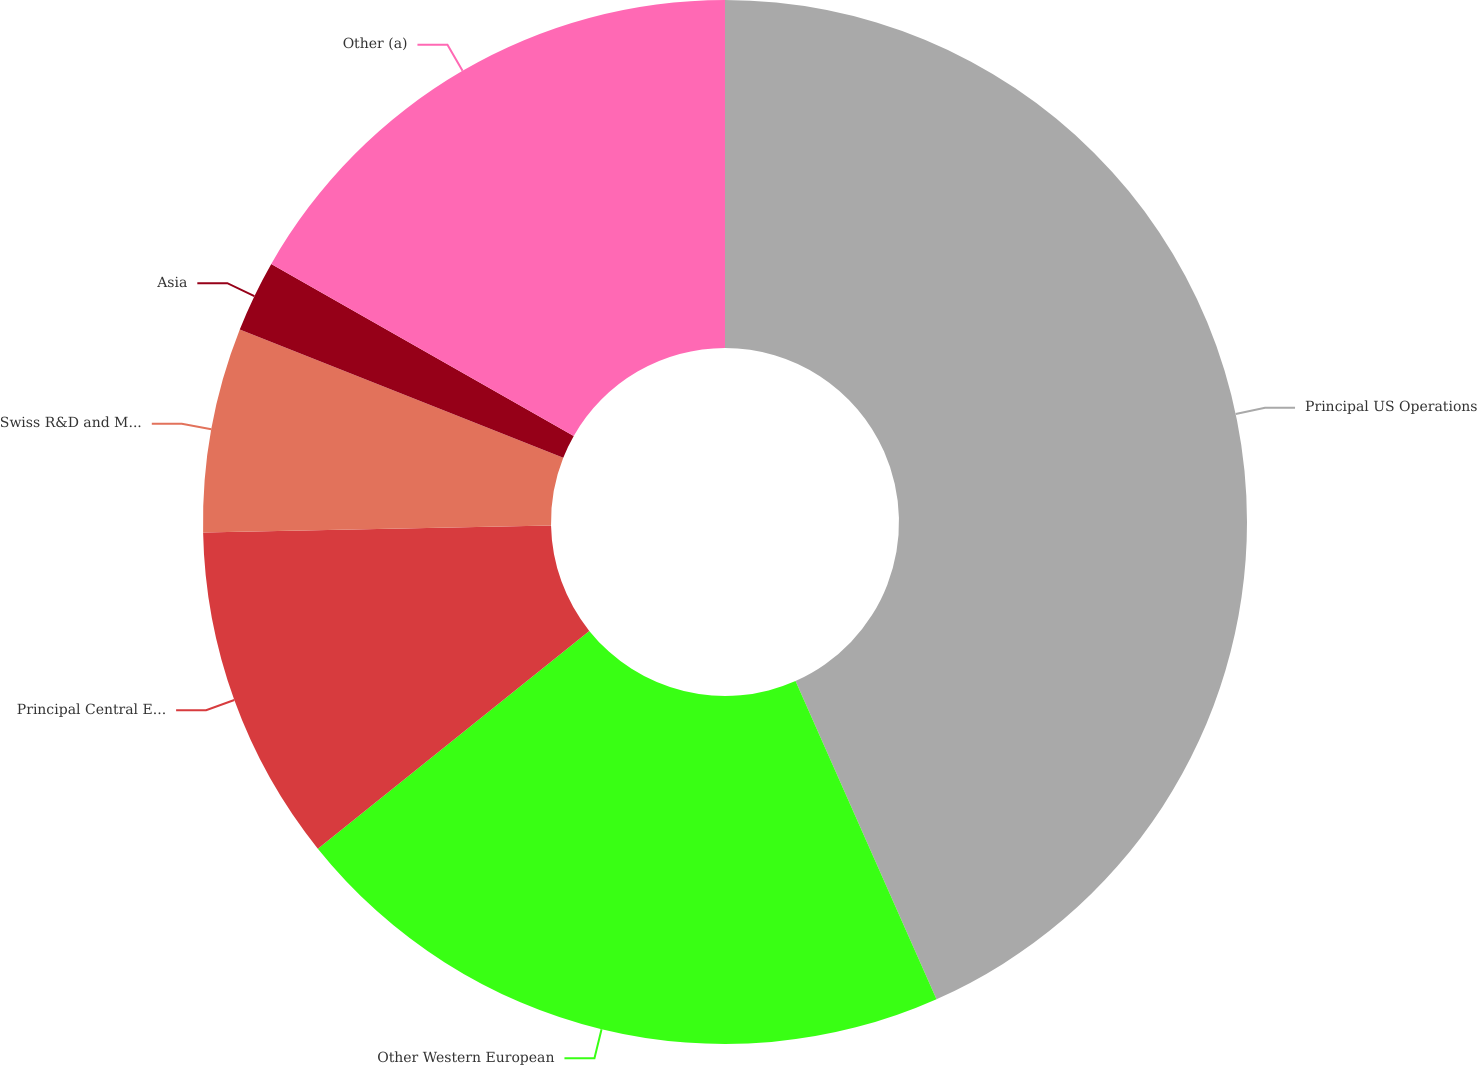Convert chart. <chart><loc_0><loc_0><loc_500><loc_500><pie_chart><fcel>Principal US Operations<fcel>Other Western European<fcel>Principal Central European<fcel>Swiss R&D and Mfg Operations<fcel>Asia<fcel>Other (a)<nl><fcel>43.36%<fcel>20.88%<fcel>10.44%<fcel>6.33%<fcel>2.22%<fcel>16.77%<nl></chart> 